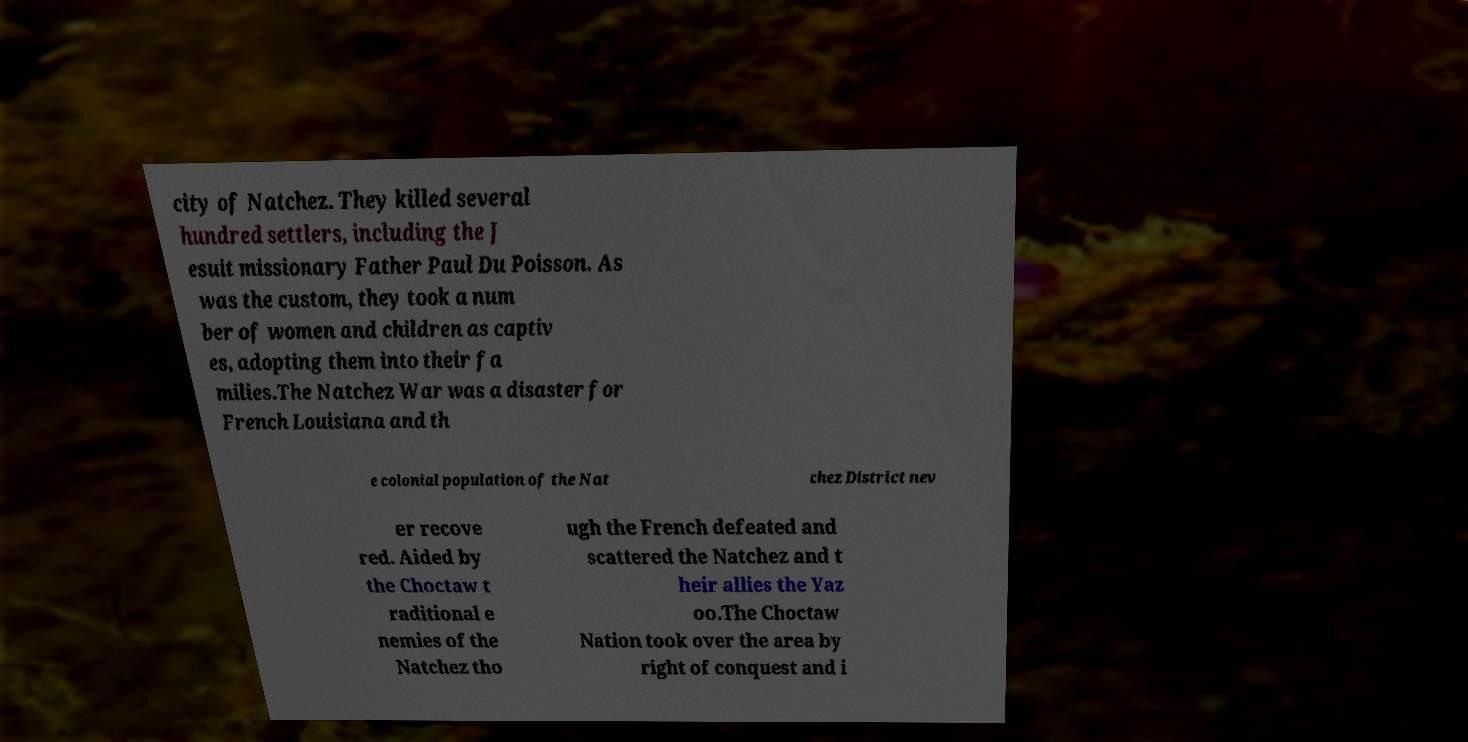Can you accurately transcribe the text from the provided image for me? city of Natchez. They killed several hundred settlers, including the J esuit missionary Father Paul Du Poisson. As was the custom, they took a num ber of women and children as captiv es, adopting them into their fa milies.The Natchez War was a disaster for French Louisiana and th e colonial population of the Nat chez District nev er recove red. Aided by the Choctaw t raditional e nemies of the Natchez tho ugh the French defeated and scattered the Natchez and t heir allies the Yaz oo.The Choctaw Nation took over the area by right of conquest and i 